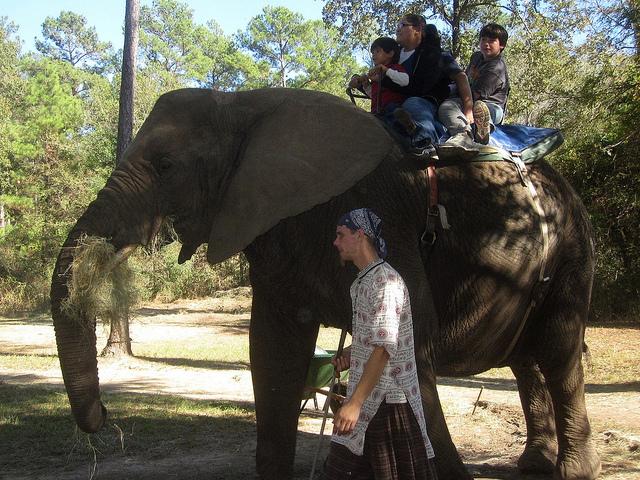Is raining?
Concise answer only. No. Are the people on the elephants male or female?
Write a very short answer. Male. How many people are on the elephant?
Be succinct. 3. Is the elephant eating?
Concise answer only. Yes. How many people are in this picture?
Short answer required. 4. How many people are on top of the elephant?
Short answer required. 4. 